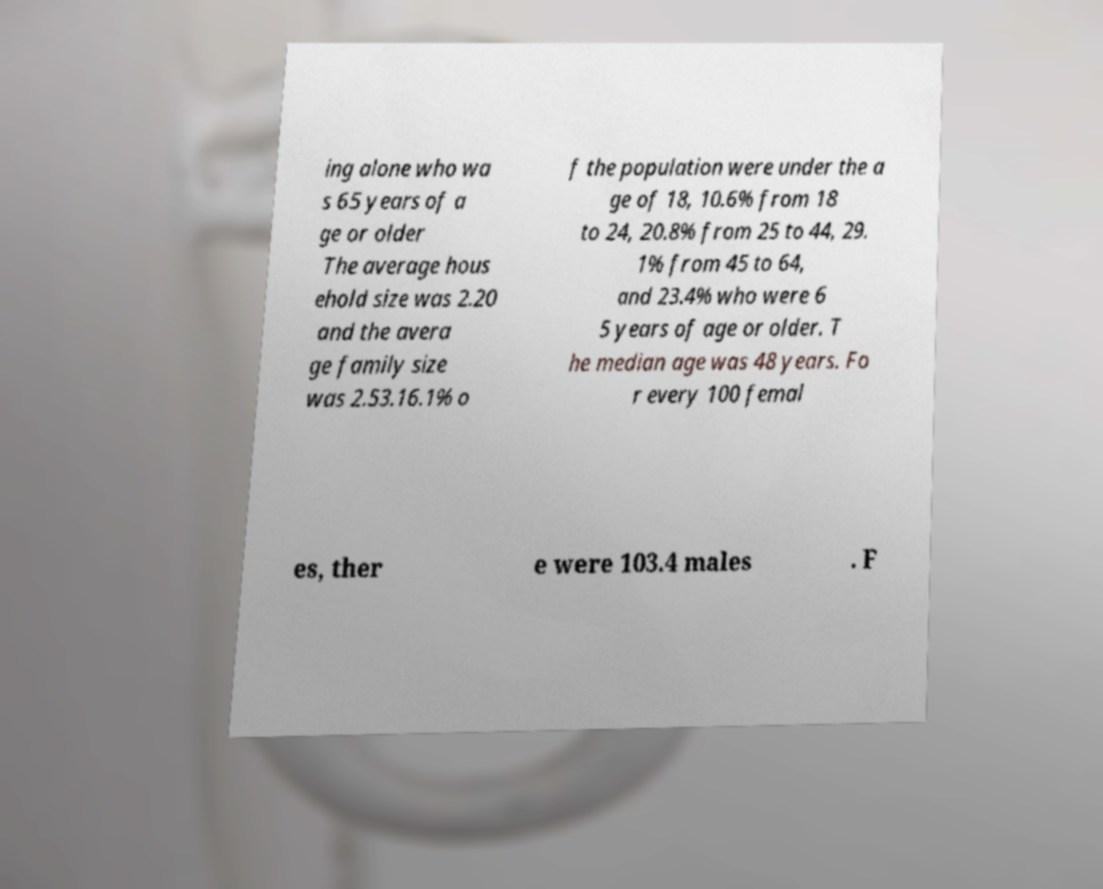For documentation purposes, I need the text within this image transcribed. Could you provide that? ing alone who wa s 65 years of a ge or older The average hous ehold size was 2.20 and the avera ge family size was 2.53.16.1% o f the population were under the a ge of 18, 10.6% from 18 to 24, 20.8% from 25 to 44, 29. 1% from 45 to 64, and 23.4% who were 6 5 years of age or older. T he median age was 48 years. Fo r every 100 femal es, ther e were 103.4 males . F 